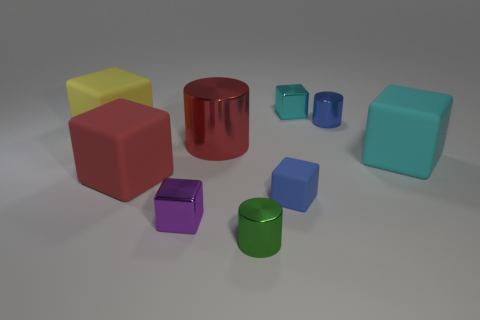What is the shape of the metallic object that is the same color as the tiny rubber thing?
Your response must be concise. Cylinder. The rubber cube that is the same color as the big cylinder is what size?
Your answer should be compact. Large. The yellow object is what size?
Your response must be concise. Large. What number of tiny metal cylinders are right of the tiny blue block?
Your response must be concise. 1. What is the size of the rubber block right of the tiny blue cylinder that is behind the tiny purple object?
Make the answer very short. Large. There is a tiny metal thing on the left side of the tiny green metallic cylinder; does it have the same shape as the blue object behind the red shiny object?
Keep it short and to the point. No. What is the shape of the big metal thing behind the small blue matte cube in front of the tiny cyan metal object?
Your response must be concise. Cylinder. There is a rubber cube that is left of the big shiny cylinder and behind the large red rubber object; how big is it?
Provide a short and direct response. Large. Do the small matte object and the large thing that is on the right side of the tiny green thing have the same shape?
Make the answer very short. Yes. The red metallic thing that is the same shape as the blue metallic object is what size?
Make the answer very short. Large. 